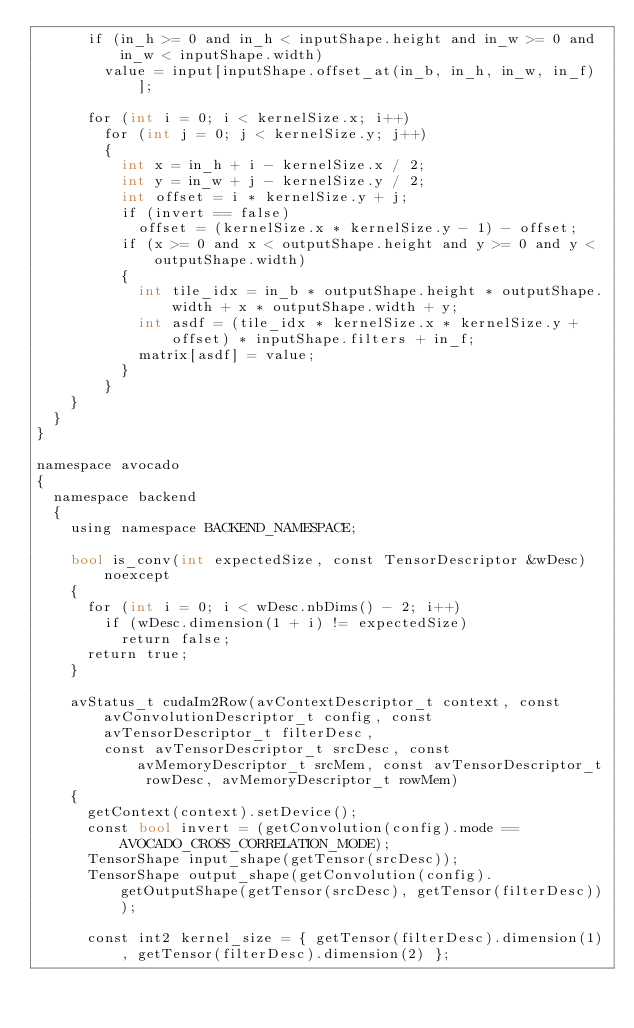Convert code to text. <code><loc_0><loc_0><loc_500><loc_500><_Cuda_>			if (in_h >= 0 and in_h < inputShape.height and in_w >= 0 and in_w < inputShape.width)
				value = input[inputShape.offset_at(in_b, in_h, in_w, in_f)];

			for (int i = 0; i < kernelSize.x; i++)
				for (int j = 0; j < kernelSize.y; j++)
				{
					int x = in_h + i - kernelSize.x / 2;
					int y = in_w + j - kernelSize.y / 2;
					int offset = i * kernelSize.y + j;
					if (invert == false)
						offset = (kernelSize.x * kernelSize.y - 1) - offset;
					if (x >= 0 and x < outputShape.height and y >= 0 and y < outputShape.width)
					{
						int tile_idx = in_b * outputShape.height * outputShape.width + x * outputShape.width + y;
						int asdf = (tile_idx * kernelSize.x * kernelSize.y + offset) * inputShape.filters + in_f;
						matrix[asdf] = value;
					}
				}
		}
	}
}

namespace avocado
{
	namespace backend
	{
		using namespace BACKEND_NAMESPACE;

		bool is_conv(int expectedSize, const TensorDescriptor &wDesc) noexcept
		{
			for (int i = 0; i < wDesc.nbDims() - 2; i++)
				if (wDesc.dimension(1 + i) != expectedSize)
					return false;
			return true;
		}

		avStatus_t cudaIm2Row(avContextDescriptor_t context, const avConvolutionDescriptor_t config, const avTensorDescriptor_t filterDesc,
				const avTensorDescriptor_t srcDesc, const avMemoryDescriptor_t srcMem, const avTensorDescriptor_t rowDesc, avMemoryDescriptor_t rowMem)
		{
			getContext(context).setDevice();
			const bool invert = (getConvolution(config).mode == AVOCADO_CROSS_CORRELATION_MODE);
			TensorShape input_shape(getTensor(srcDesc));
			TensorShape output_shape(getConvolution(config).getOutputShape(getTensor(srcDesc), getTensor(filterDesc)));

			const int2 kernel_size = { getTensor(filterDesc).dimension(1), getTensor(filterDesc).dimension(2) };</code> 